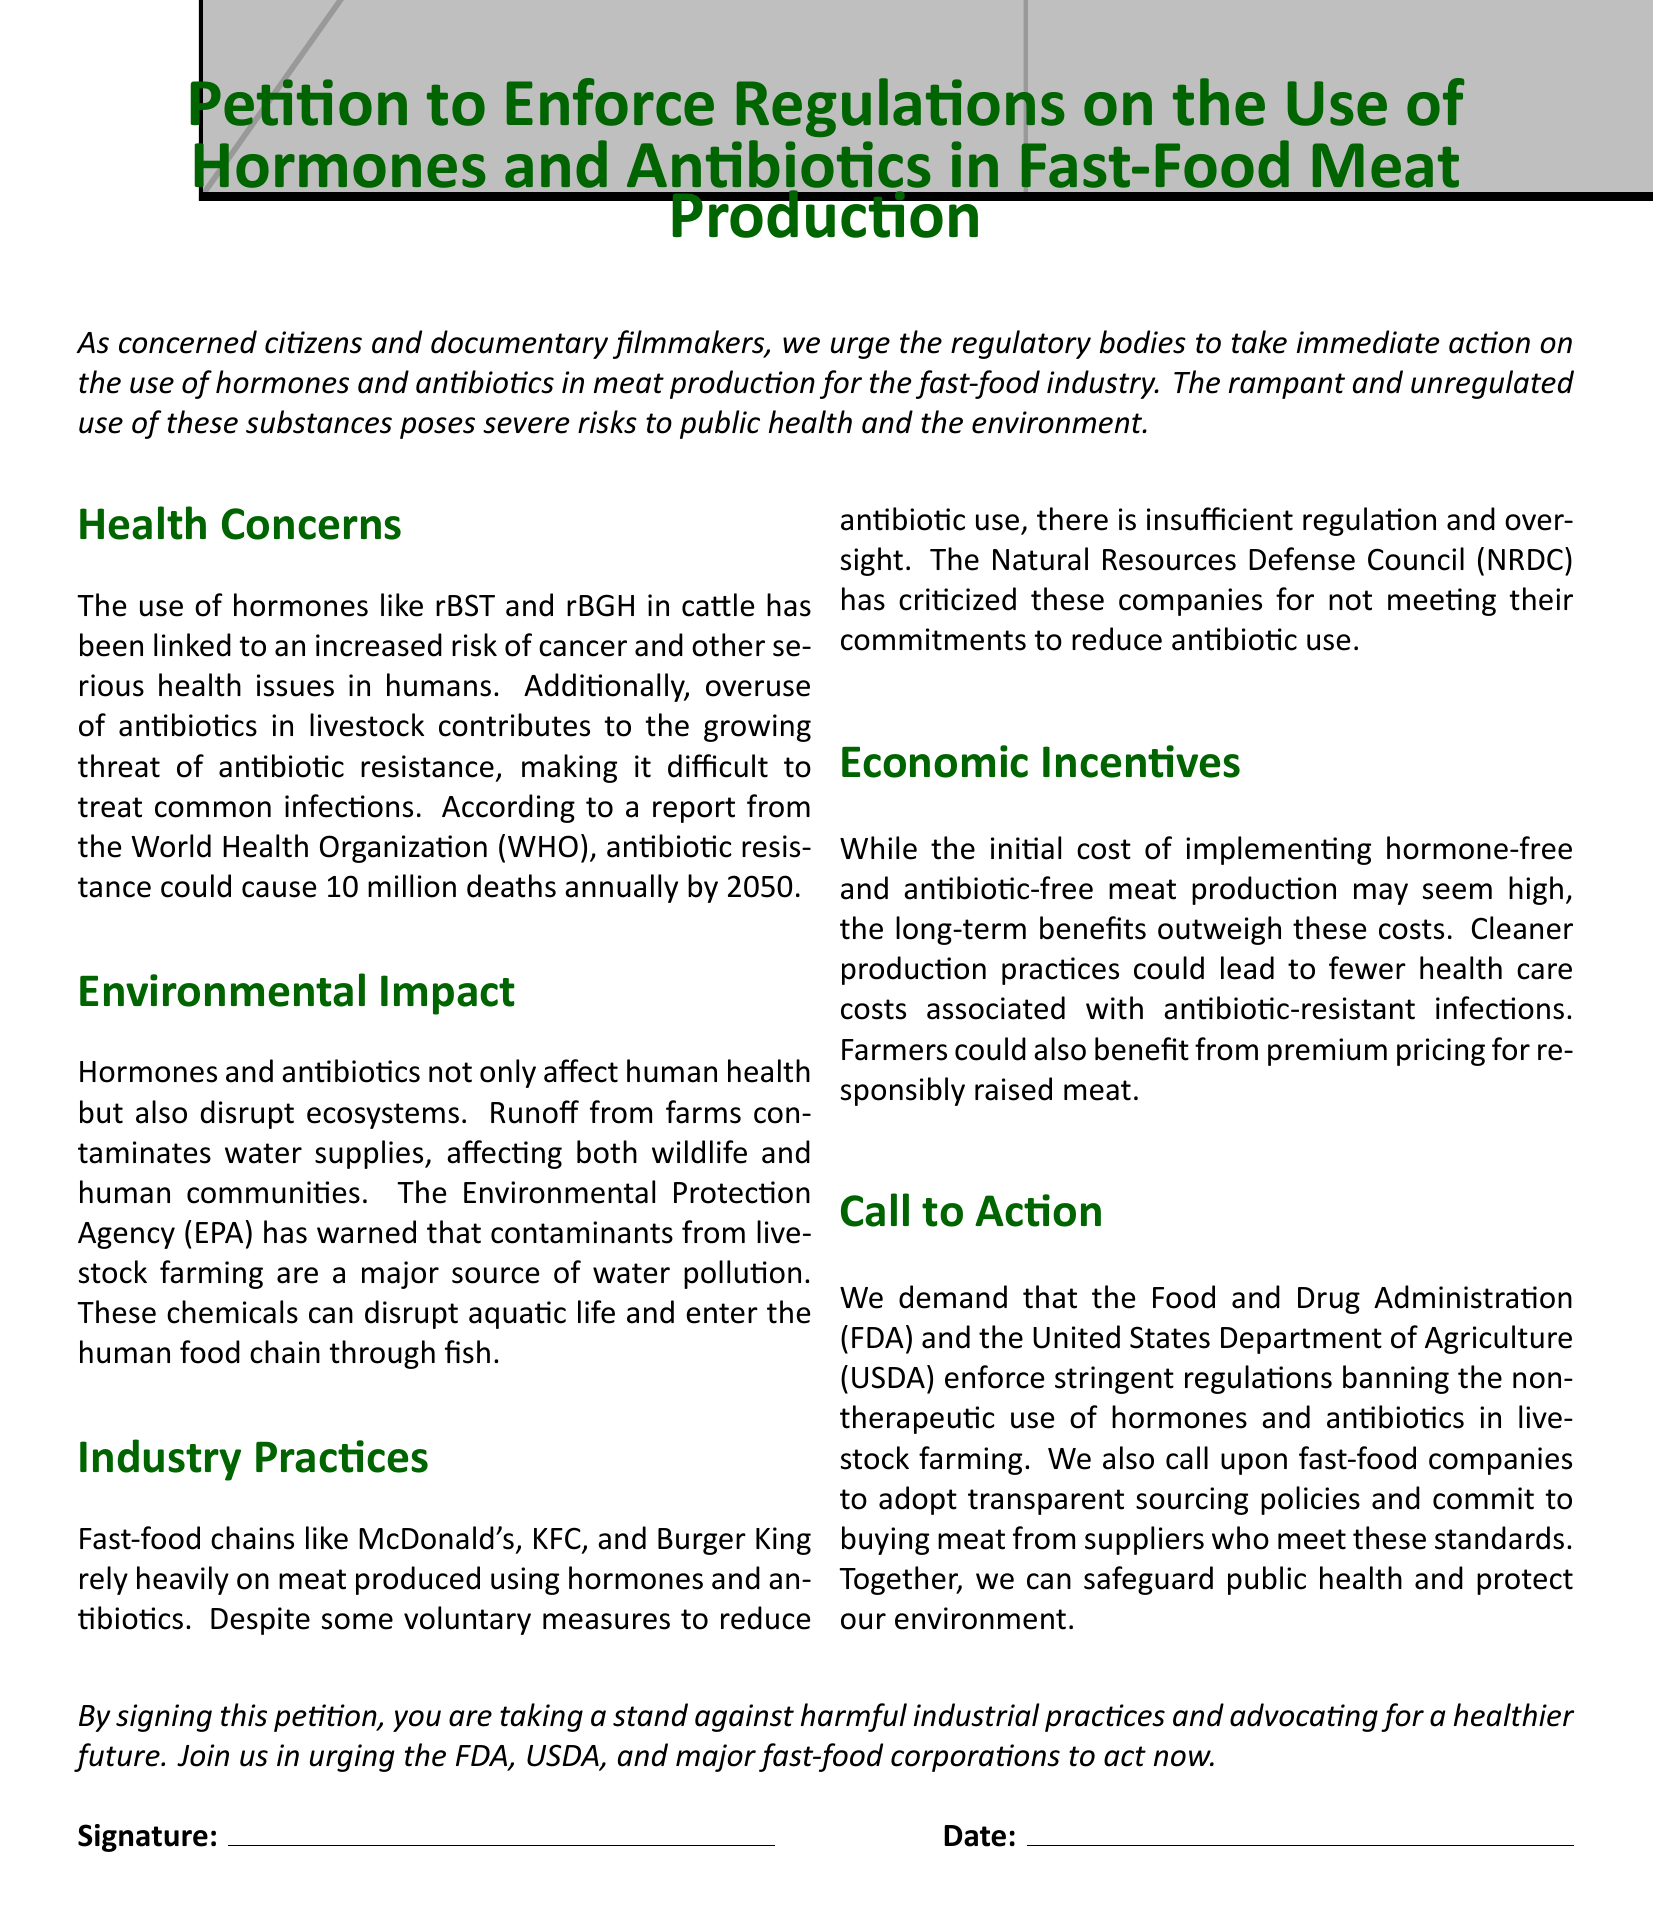What is the main purpose of this petition? The main purpose is to urge regulatory bodies to take immediate action on the use of hormones and antibiotics in meat production for the fast-food industry.
Answer: Urge regulatory bodies for immediate action Which organizations are called upon to enforce regulations? The petition specifically calls upon the Food and Drug Administration (FDA) and the United States Department of Agriculture (USDA).
Answer: FDA and USDA How many deaths could antibiotic resistance cause annually by 2050, according to WHO? The World Health Organization (WHO) states that antibiotic resistance could cause 10 million deaths annually by 2050.
Answer: 10 million What is a major source of water pollution mentioned in the document? Contaminants from livestock farming are identified as a major source of water pollution.
Answer: Contaminants from livestock farming What do fast-food chains rely heavily on according to the petition? Fast-food chains like McDonald's, KFC, and Burger King rely heavily on meat produced using hormones and antibiotics.
Answer: Hormones and antibiotics What is mentioned as a benefit of implementing hormone-free and antibiotic-free meat production? The long-term benefits include fewer health care costs associated with antibiotic-resistant infections.
Answer: Fewer health care costs Which environmental agency has warned about pollutants from farms? The Environmental Protection Agency (EPA) has warned that contaminants from livestock farming are a major source of water pollution.
Answer: Environmental Protection Agency (EPA) Which organization criticized fast-food companies for their commitments? The Natural Resources Defense Council (NRDC) criticized these companies for not meeting their commitments to reduce antibiotic use.
Answer: Natural Resources Defense Council (NRDC) 